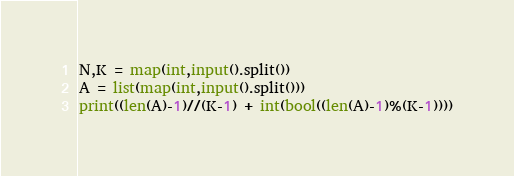<code> <loc_0><loc_0><loc_500><loc_500><_Python_>N,K = map(int,input().split())
A = list(map(int,input().split()))
print((len(A)-1)//(K-1) + int(bool((len(A)-1)%(K-1))))</code> 